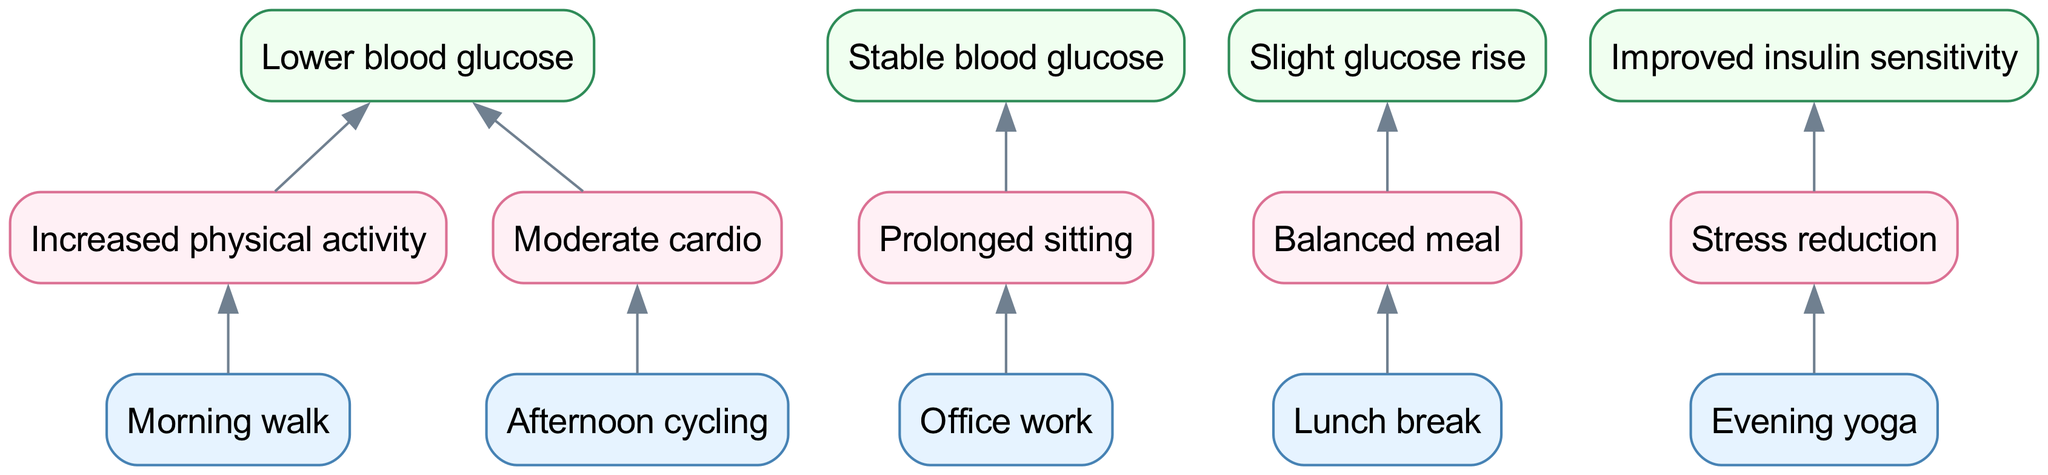What is the top-level outcome of increased physical activity? Increased physical activity is connected to the node labeled "Lower blood glucose" in the top level of the diagram, indicating that it results in a decrease in blood glucose levels.
Answer: Lower blood glucose How many bottom-level activities are listed in the diagram? There are five bottom-level activities shown: Morning walk, Office work, Lunch break, Afternoon cycling, and Evening yoga. Counting these gives us the total number of bottom-level activities.
Answer: 5 What does prolonged sitting lead to in terms of blood glucose levels? Prolonged sitting is linked to the outcome "Stable blood glucose," indicating that it does not significantly alter blood glucose levels while seated for long periods.
Answer: Stable blood glucose Which daily activity is associated with stress reduction? Evening yoga is directly linked to the middle-level node "Stress reduction," indicating that this activity helps in reducing stress.
Answer: Evening yoga If a person engages in moderate cardio, what effect does it have on their blood glucose? The diagram connects moderate cardio to the outcome "Lower blood glucose," meaning that engaging in moderate cardio effectively reduces blood glucose levels.
Answer: Lower blood glucose What are the middle-level effects associated with lunch break? The lunch break is connected to "Balanced meal," suggesting that taking a break for lunch can result in eating a meal that helps balance blood glucose levels.
Answer: Balanced meal How many edges connect the bottom-level to the middle-level? Each bottom-level activity connects to one middle-level effect, leading to a total of five edges as each of the five activities has a unique connection to the middle level.
Answer: 5 What is the relationship between afternoon cycling and blood glucose levels? Afternoon cycling connects to the "Moderate cardio" node in the middle level, which subsequently leads to "Lower blood glucose" in the top level, showing a pathway of impact on blood glucose levels.
Answer: Lower blood glucose What is the result of a balanced meal according to the diagram? The balanced meal connects to "Slight glucose rise," meaning that consuming a balanced meal can lead to a minor increase in blood glucose levels as indicated in the top level of the diagram.
Answer: Slight glucose rise 